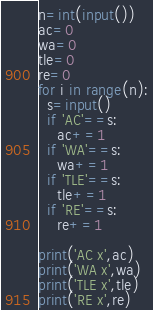<code> <loc_0><loc_0><loc_500><loc_500><_Python_>n=int(input())
ac=0
wa=0
tle=0
re=0
for i in range(n):
  s=input()
  if 'AC'==s:
    ac+=1
  if 'WA'==s:
    wa+=1
  if 'TLE'==s:
    tle+=1
  if 'RE'==s:
    re+=1

print('AC x',ac)
print('WA x',wa)
print('TLE x',tle)
print('RE x',re)</code> 